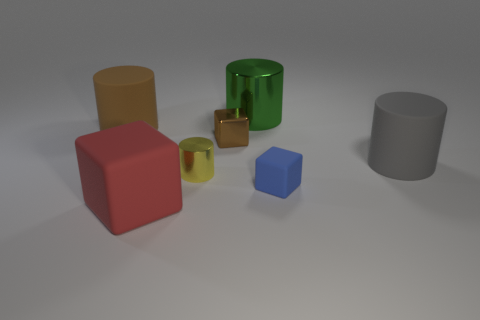Subtract all yellow cylinders. How many cylinders are left? 3 Subtract all purple cylinders. Subtract all brown blocks. How many cylinders are left? 4 Add 2 small cubes. How many objects exist? 9 Subtract all cylinders. How many objects are left? 3 Add 3 small blue spheres. How many small blue spheres exist? 3 Subtract 0 cyan cylinders. How many objects are left? 7 Subtract all tiny cyan cubes. Subtract all green shiny things. How many objects are left? 6 Add 7 gray matte things. How many gray matte things are left? 8 